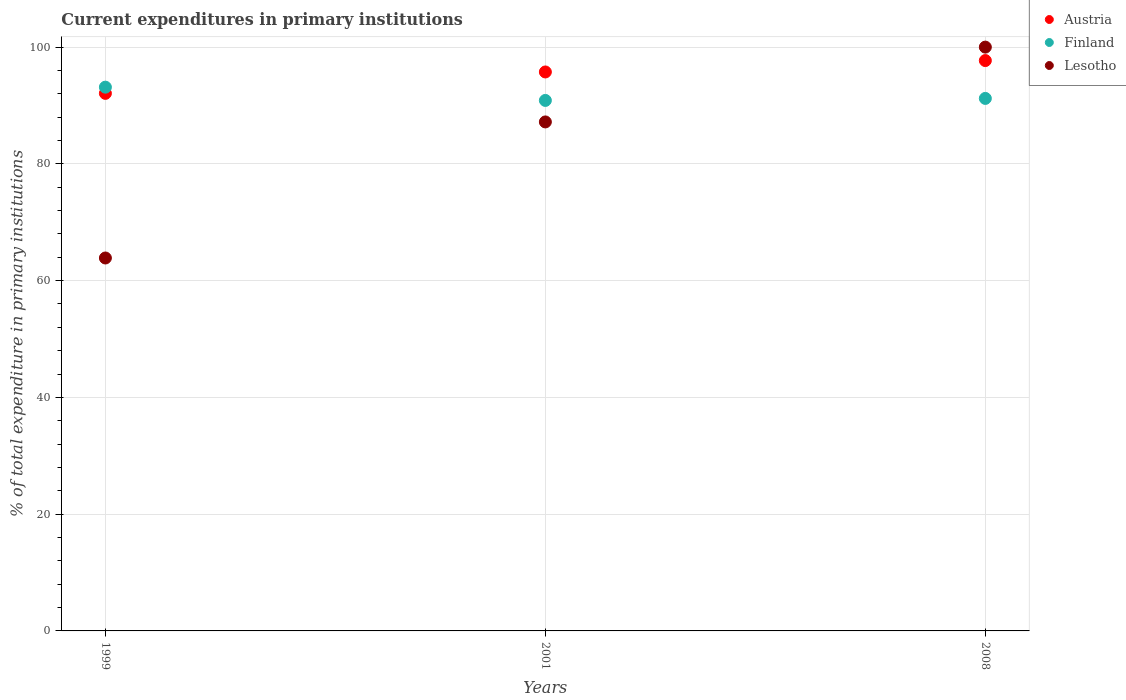What is the current expenditures in primary institutions in Lesotho in 1999?
Provide a short and direct response. 63.88. Across all years, what is the maximum current expenditures in primary institutions in Finland?
Give a very brief answer. 93.14. Across all years, what is the minimum current expenditures in primary institutions in Austria?
Provide a short and direct response. 92.08. In which year was the current expenditures in primary institutions in Finland minimum?
Your response must be concise. 2001. What is the total current expenditures in primary institutions in Austria in the graph?
Give a very brief answer. 285.52. What is the difference between the current expenditures in primary institutions in Lesotho in 2001 and that in 2008?
Offer a very short reply. -12.81. What is the difference between the current expenditures in primary institutions in Finland in 1999 and the current expenditures in primary institutions in Austria in 2001?
Make the answer very short. -2.6. What is the average current expenditures in primary institutions in Austria per year?
Ensure brevity in your answer.  95.17. In the year 1999, what is the difference between the current expenditures in primary institutions in Lesotho and current expenditures in primary institutions in Austria?
Make the answer very short. -28.2. In how many years, is the current expenditures in primary institutions in Finland greater than 8 %?
Give a very brief answer. 3. What is the ratio of the current expenditures in primary institutions in Austria in 2001 to that in 2008?
Make the answer very short. 0.98. Is the current expenditures in primary institutions in Lesotho in 2001 less than that in 2008?
Your answer should be very brief. Yes. What is the difference between the highest and the second highest current expenditures in primary institutions in Austria?
Ensure brevity in your answer.  1.95. What is the difference between the highest and the lowest current expenditures in primary institutions in Austria?
Offer a terse response. 5.62. Is it the case that in every year, the sum of the current expenditures in primary institutions in Austria and current expenditures in primary institutions in Lesotho  is greater than the current expenditures in primary institutions in Finland?
Your response must be concise. Yes. Are the values on the major ticks of Y-axis written in scientific E-notation?
Offer a very short reply. No. Does the graph contain grids?
Offer a terse response. Yes. Where does the legend appear in the graph?
Your answer should be compact. Top right. How many legend labels are there?
Offer a terse response. 3. What is the title of the graph?
Offer a terse response. Current expenditures in primary institutions. Does "Cyprus" appear as one of the legend labels in the graph?
Make the answer very short. No. What is the label or title of the Y-axis?
Make the answer very short. % of total expenditure in primary institutions. What is the % of total expenditure in primary institutions in Austria in 1999?
Make the answer very short. 92.08. What is the % of total expenditure in primary institutions of Finland in 1999?
Make the answer very short. 93.14. What is the % of total expenditure in primary institutions in Lesotho in 1999?
Give a very brief answer. 63.88. What is the % of total expenditure in primary institutions in Austria in 2001?
Offer a terse response. 95.75. What is the % of total expenditure in primary institutions of Finland in 2001?
Your response must be concise. 90.87. What is the % of total expenditure in primary institutions of Lesotho in 2001?
Ensure brevity in your answer.  87.19. What is the % of total expenditure in primary institutions of Austria in 2008?
Provide a succinct answer. 97.7. What is the % of total expenditure in primary institutions of Finland in 2008?
Your answer should be very brief. 91.21. What is the % of total expenditure in primary institutions of Lesotho in 2008?
Provide a succinct answer. 100. Across all years, what is the maximum % of total expenditure in primary institutions of Austria?
Provide a short and direct response. 97.7. Across all years, what is the maximum % of total expenditure in primary institutions in Finland?
Keep it short and to the point. 93.14. Across all years, what is the minimum % of total expenditure in primary institutions in Austria?
Your answer should be compact. 92.08. Across all years, what is the minimum % of total expenditure in primary institutions in Finland?
Give a very brief answer. 90.87. Across all years, what is the minimum % of total expenditure in primary institutions of Lesotho?
Provide a short and direct response. 63.88. What is the total % of total expenditure in primary institutions in Austria in the graph?
Make the answer very short. 285.52. What is the total % of total expenditure in primary institutions of Finland in the graph?
Ensure brevity in your answer.  275.22. What is the total % of total expenditure in primary institutions in Lesotho in the graph?
Provide a succinct answer. 251.06. What is the difference between the % of total expenditure in primary institutions in Austria in 1999 and that in 2001?
Offer a very short reply. -3.67. What is the difference between the % of total expenditure in primary institutions of Finland in 1999 and that in 2001?
Offer a very short reply. 2.27. What is the difference between the % of total expenditure in primary institutions of Lesotho in 1999 and that in 2001?
Provide a short and direct response. -23.31. What is the difference between the % of total expenditure in primary institutions of Austria in 1999 and that in 2008?
Your answer should be compact. -5.62. What is the difference between the % of total expenditure in primary institutions in Finland in 1999 and that in 2008?
Make the answer very short. 1.93. What is the difference between the % of total expenditure in primary institutions in Lesotho in 1999 and that in 2008?
Your answer should be compact. -36.12. What is the difference between the % of total expenditure in primary institutions of Austria in 2001 and that in 2008?
Ensure brevity in your answer.  -1.95. What is the difference between the % of total expenditure in primary institutions of Finland in 2001 and that in 2008?
Give a very brief answer. -0.34. What is the difference between the % of total expenditure in primary institutions of Lesotho in 2001 and that in 2008?
Provide a short and direct response. -12.81. What is the difference between the % of total expenditure in primary institutions in Austria in 1999 and the % of total expenditure in primary institutions in Finland in 2001?
Give a very brief answer. 1.21. What is the difference between the % of total expenditure in primary institutions of Austria in 1999 and the % of total expenditure in primary institutions of Lesotho in 2001?
Your answer should be compact. 4.89. What is the difference between the % of total expenditure in primary institutions of Finland in 1999 and the % of total expenditure in primary institutions of Lesotho in 2001?
Offer a terse response. 5.95. What is the difference between the % of total expenditure in primary institutions in Austria in 1999 and the % of total expenditure in primary institutions in Finland in 2008?
Ensure brevity in your answer.  0.87. What is the difference between the % of total expenditure in primary institutions of Austria in 1999 and the % of total expenditure in primary institutions of Lesotho in 2008?
Provide a succinct answer. -7.92. What is the difference between the % of total expenditure in primary institutions of Finland in 1999 and the % of total expenditure in primary institutions of Lesotho in 2008?
Keep it short and to the point. -6.86. What is the difference between the % of total expenditure in primary institutions of Austria in 2001 and the % of total expenditure in primary institutions of Finland in 2008?
Your response must be concise. 4.53. What is the difference between the % of total expenditure in primary institutions of Austria in 2001 and the % of total expenditure in primary institutions of Lesotho in 2008?
Your answer should be very brief. -4.25. What is the difference between the % of total expenditure in primary institutions in Finland in 2001 and the % of total expenditure in primary institutions in Lesotho in 2008?
Give a very brief answer. -9.13. What is the average % of total expenditure in primary institutions in Austria per year?
Make the answer very short. 95.17. What is the average % of total expenditure in primary institutions in Finland per year?
Make the answer very short. 91.74. What is the average % of total expenditure in primary institutions in Lesotho per year?
Provide a short and direct response. 83.69. In the year 1999, what is the difference between the % of total expenditure in primary institutions in Austria and % of total expenditure in primary institutions in Finland?
Your response must be concise. -1.06. In the year 1999, what is the difference between the % of total expenditure in primary institutions of Austria and % of total expenditure in primary institutions of Lesotho?
Your response must be concise. 28.2. In the year 1999, what is the difference between the % of total expenditure in primary institutions in Finland and % of total expenditure in primary institutions in Lesotho?
Make the answer very short. 29.26. In the year 2001, what is the difference between the % of total expenditure in primary institutions in Austria and % of total expenditure in primary institutions in Finland?
Offer a terse response. 4.88. In the year 2001, what is the difference between the % of total expenditure in primary institutions of Austria and % of total expenditure in primary institutions of Lesotho?
Offer a terse response. 8.56. In the year 2001, what is the difference between the % of total expenditure in primary institutions of Finland and % of total expenditure in primary institutions of Lesotho?
Your answer should be compact. 3.68. In the year 2008, what is the difference between the % of total expenditure in primary institutions of Austria and % of total expenditure in primary institutions of Finland?
Keep it short and to the point. 6.48. In the year 2008, what is the difference between the % of total expenditure in primary institutions of Austria and % of total expenditure in primary institutions of Lesotho?
Keep it short and to the point. -2.3. In the year 2008, what is the difference between the % of total expenditure in primary institutions in Finland and % of total expenditure in primary institutions in Lesotho?
Your answer should be very brief. -8.79. What is the ratio of the % of total expenditure in primary institutions in Austria in 1999 to that in 2001?
Make the answer very short. 0.96. What is the ratio of the % of total expenditure in primary institutions of Finland in 1999 to that in 2001?
Your response must be concise. 1.02. What is the ratio of the % of total expenditure in primary institutions of Lesotho in 1999 to that in 2001?
Make the answer very short. 0.73. What is the ratio of the % of total expenditure in primary institutions of Austria in 1999 to that in 2008?
Keep it short and to the point. 0.94. What is the ratio of the % of total expenditure in primary institutions of Finland in 1999 to that in 2008?
Your response must be concise. 1.02. What is the ratio of the % of total expenditure in primary institutions in Lesotho in 1999 to that in 2008?
Give a very brief answer. 0.64. What is the ratio of the % of total expenditure in primary institutions of Finland in 2001 to that in 2008?
Your answer should be compact. 1. What is the ratio of the % of total expenditure in primary institutions in Lesotho in 2001 to that in 2008?
Offer a very short reply. 0.87. What is the difference between the highest and the second highest % of total expenditure in primary institutions in Austria?
Provide a succinct answer. 1.95. What is the difference between the highest and the second highest % of total expenditure in primary institutions in Finland?
Ensure brevity in your answer.  1.93. What is the difference between the highest and the second highest % of total expenditure in primary institutions in Lesotho?
Your answer should be very brief. 12.81. What is the difference between the highest and the lowest % of total expenditure in primary institutions of Austria?
Ensure brevity in your answer.  5.62. What is the difference between the highest and the lowest % of total expenditure in primary institutions of Finland?
Your answer should be compact. 2.27. What is the difference between the highest and the lowest % of total expenditure in primary institutions of Lesotho?
Keep it short and to the point. 36.12. 